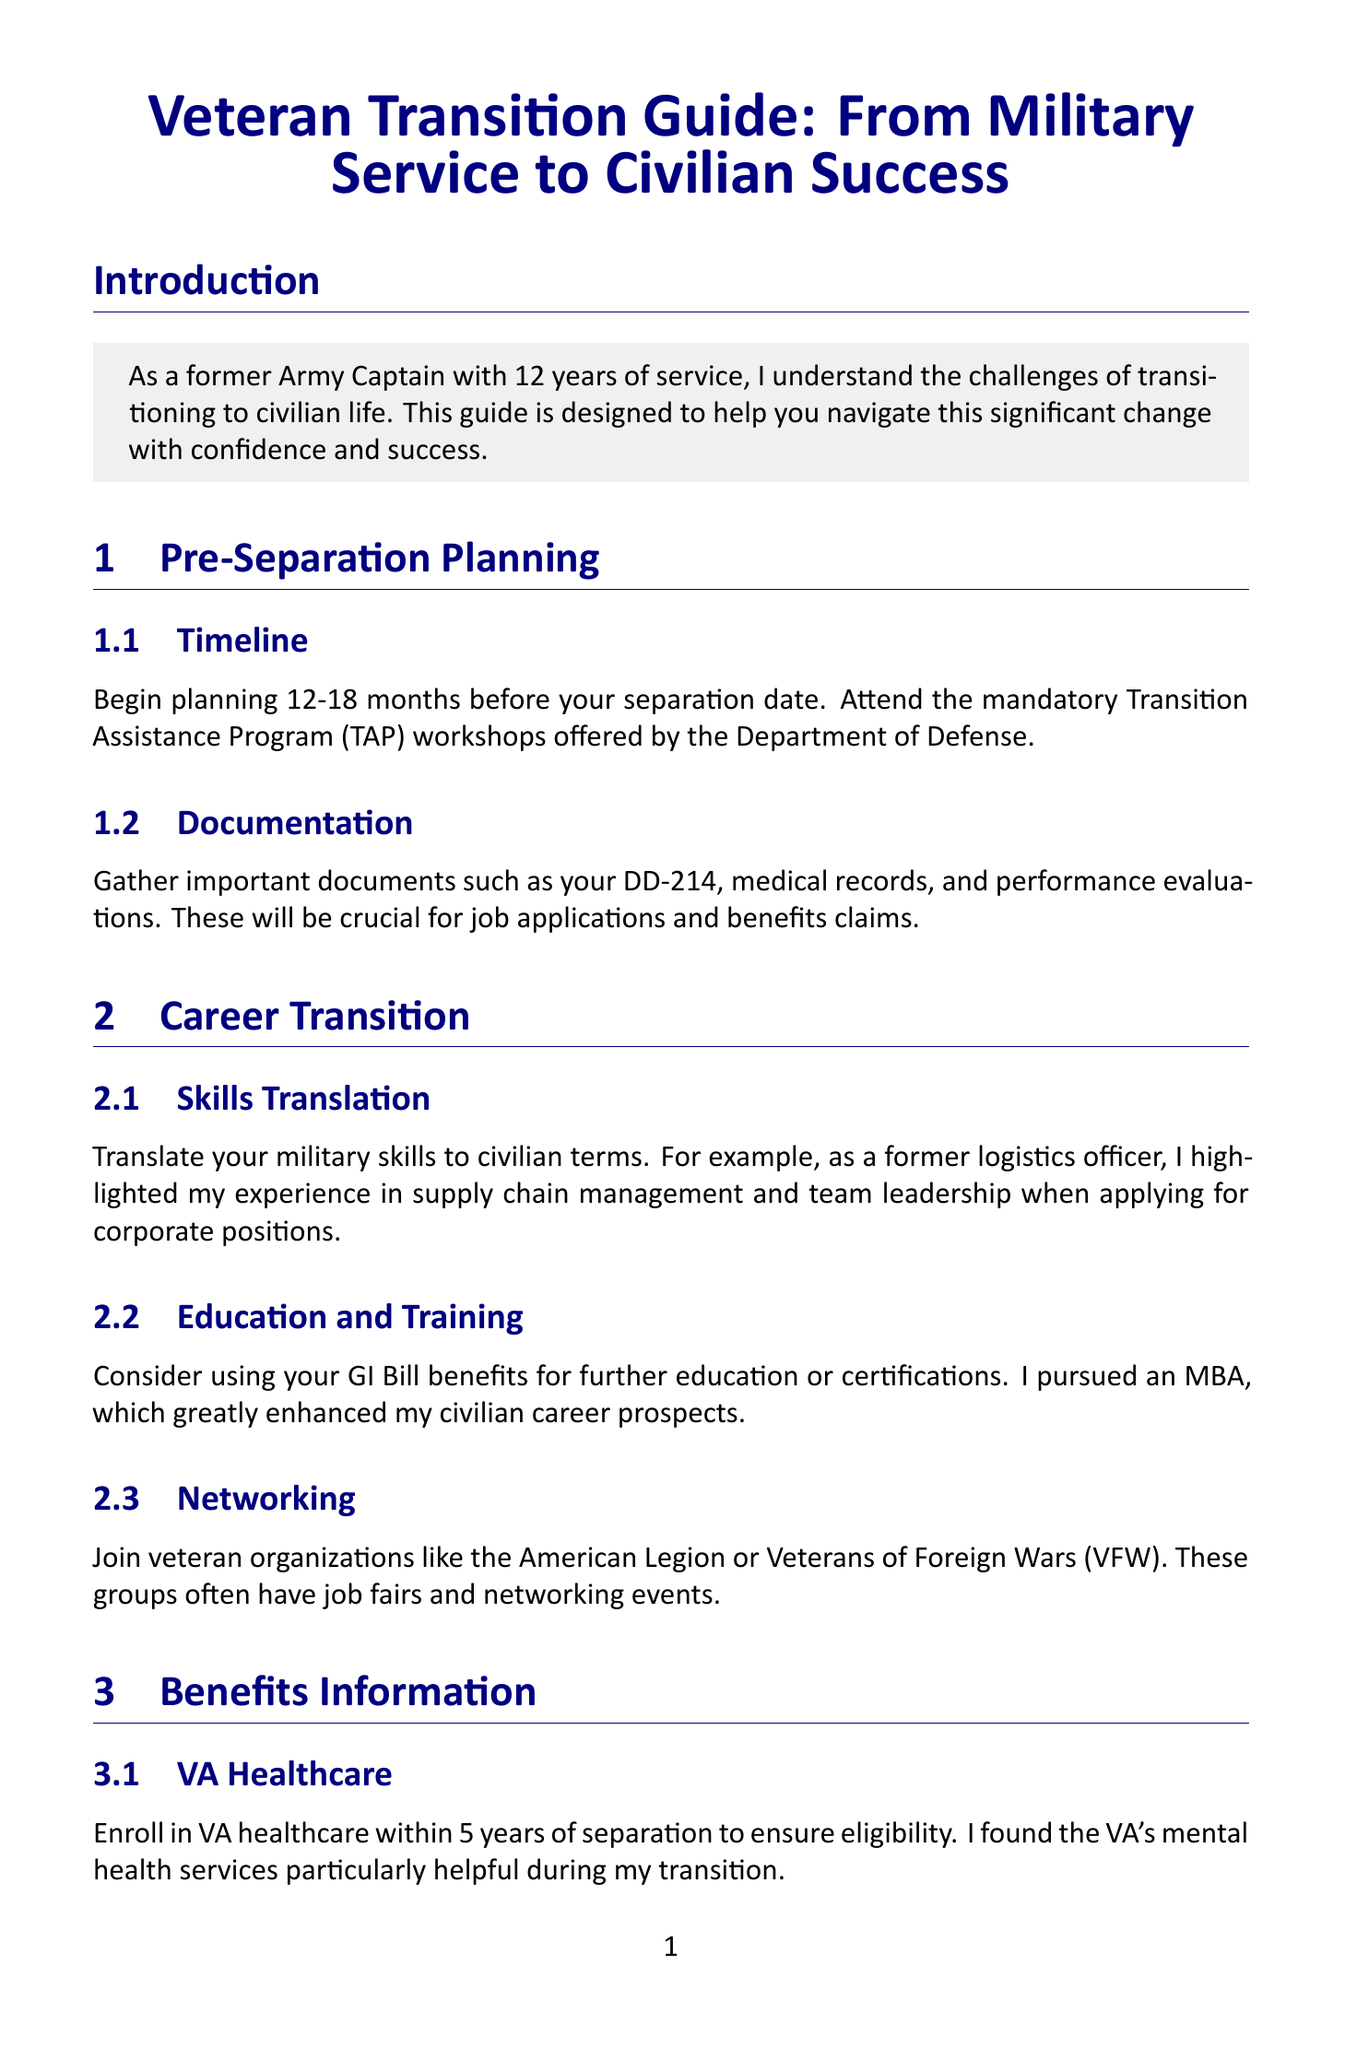What is the primary purpose of this guide? The guide aims to help service members navigate the transition to civilian life with confidence and success.
Answer: Help navigate transition When should planning begin before separation? The document states that planning should begin 12-18 months before the separation date.
Answer: 12-18 months What program provides additional transition assistance for the Army? The Army Career and Alumni Program (ACAP) offers additional transition assistance.
Answer: ACAP How long do you have to enroll in VA healthcare after separation? The document mentions that you should enroll within 5 years of separation.
Answer: 5 years What education benefit is suggested for further education? The guide encourages using GI Bill benefits for further education or certifications.
Answer: GI Bill benefits What is a recommended action regarding family during the transition? Involving your family in the transition process is recommended.
Answer: Involve family Which organization is mentioned as a resource for mental health support? The Wounded Warrior Project is mentioned as a resource for mental health support.
Answer: Wounded Warrior Project What type of job assistance does the Marine For Life Network provide? The Marine For Life Network provides networking opportunities and job search assistance.
Answer: Networking opportunities Which program helps Navy personnel earn civilian certifications? The Navy's Credentialing Opportunities On-Line (COOL) program helps earn certifications.
Answer: COOL program 